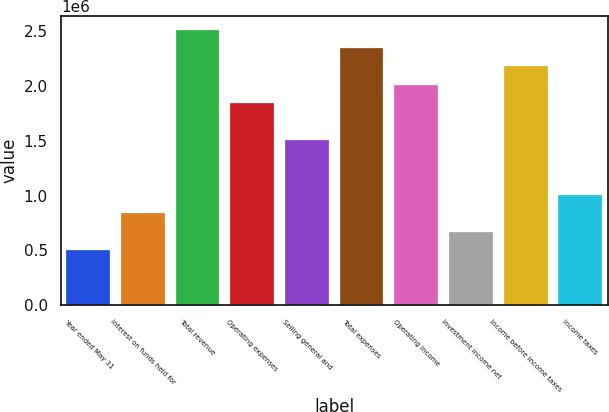Convert chart to OTSL. <chart><loc_0><loc_0><loc_500><loc_500><bar_chart><fcel>Year ended May 31<fcel>Interest on funds held for<fcel>Total revenue<fcel>Operating expenses<fcel>Selling general and<fcel>Total expenses<fcel>Operating income<fcel>Investment income net<fcel>Income before income taxes<fcel>Income taxes<nl><fcel>502379<fcel>837298<fcel>2.51189e+06<fcel>1.84206e+06<fcel>1.50714e+06<fcel>2.34443e+06<fcel>2.00952e+06<fcel>669839<fcel>2.17697e+06<fcel>1.00476e+06<nl></chart> 